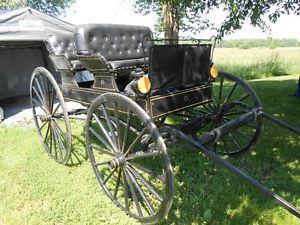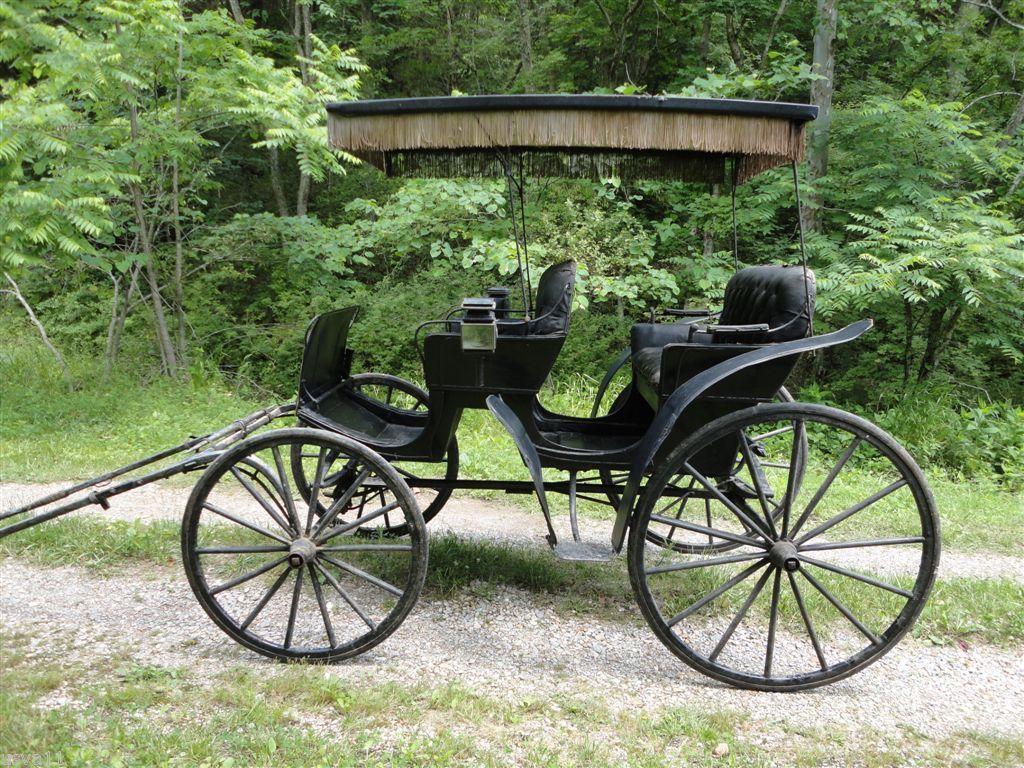The first image is the image on the left, the second image is the image on the right. Assess this claim about the two images: "An image shows a wagon with violet interior and a dark top over it.". Correct or not? Answer yes or no. No. The first image is the image on the left, the second image is the image on the right. Considering the images on both sides, is "At least one of the carriages has wheels with red spokes." valid? Answer yes or no. No. 